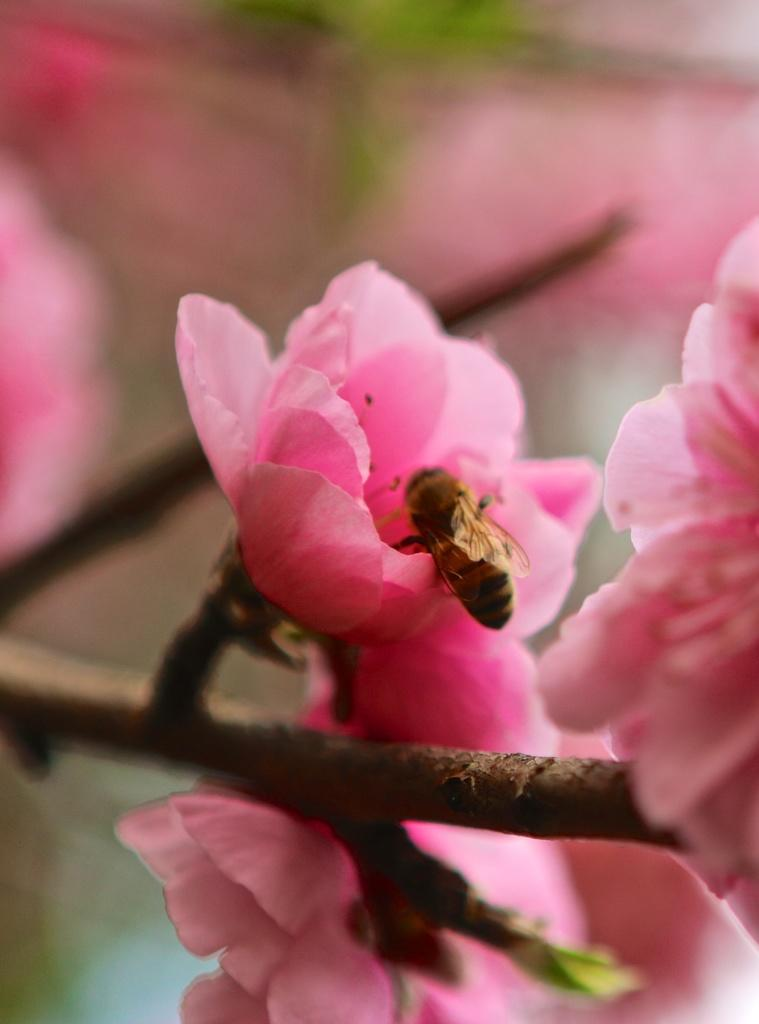What is on the flower in the image? There is an insect on the flower in the image. What color is the flower? The flower is pink. What part of the flower can be seen besides the petals? The stem of the flower is visible. How would you describe the background of the image? The background of the image is blurred and pink. What type of chicken is sitting on the flower in the image? There is no chicken present in the image; it features an insect on a pink flower with a visible stem. What angle is the ink used to draw the flower in the image? The image is a photograph, not a drawing, so there is no ink used to create it. 